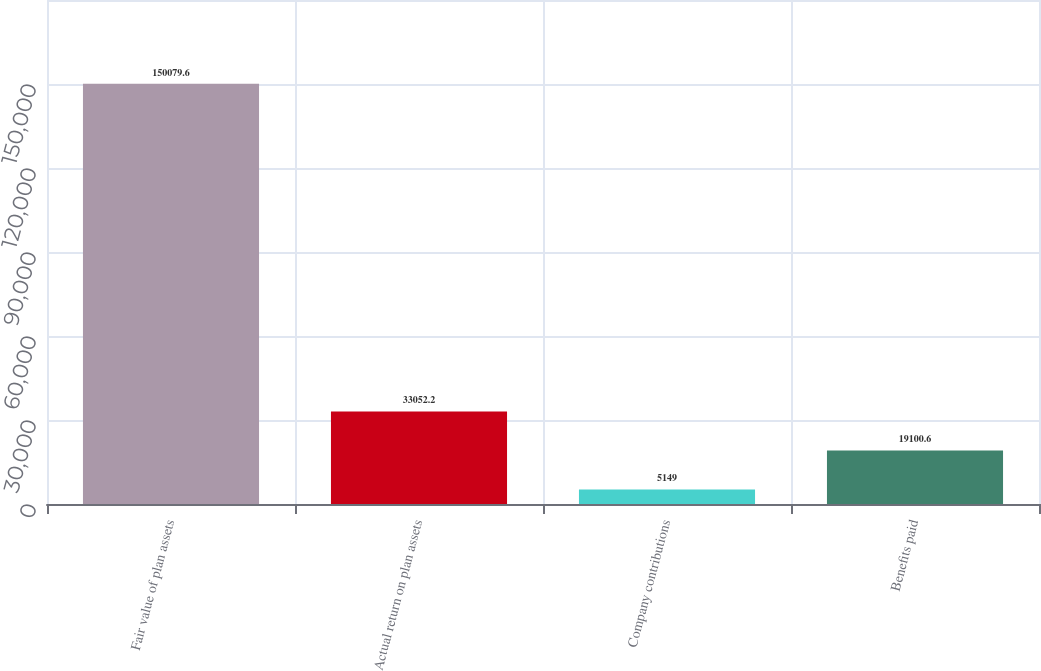Convert chart. <chart><loc_0><loc_0><loc_500><loc_500><bar_chart><fcel>Fair value of plan assets<fcel>Actual return on plan assets<fcel>Company contributions<fcel>Benefits paid<nl><fcel>150080<fcel>33052.2<fcel>5149<fcel>19100.6<nl></chart> 